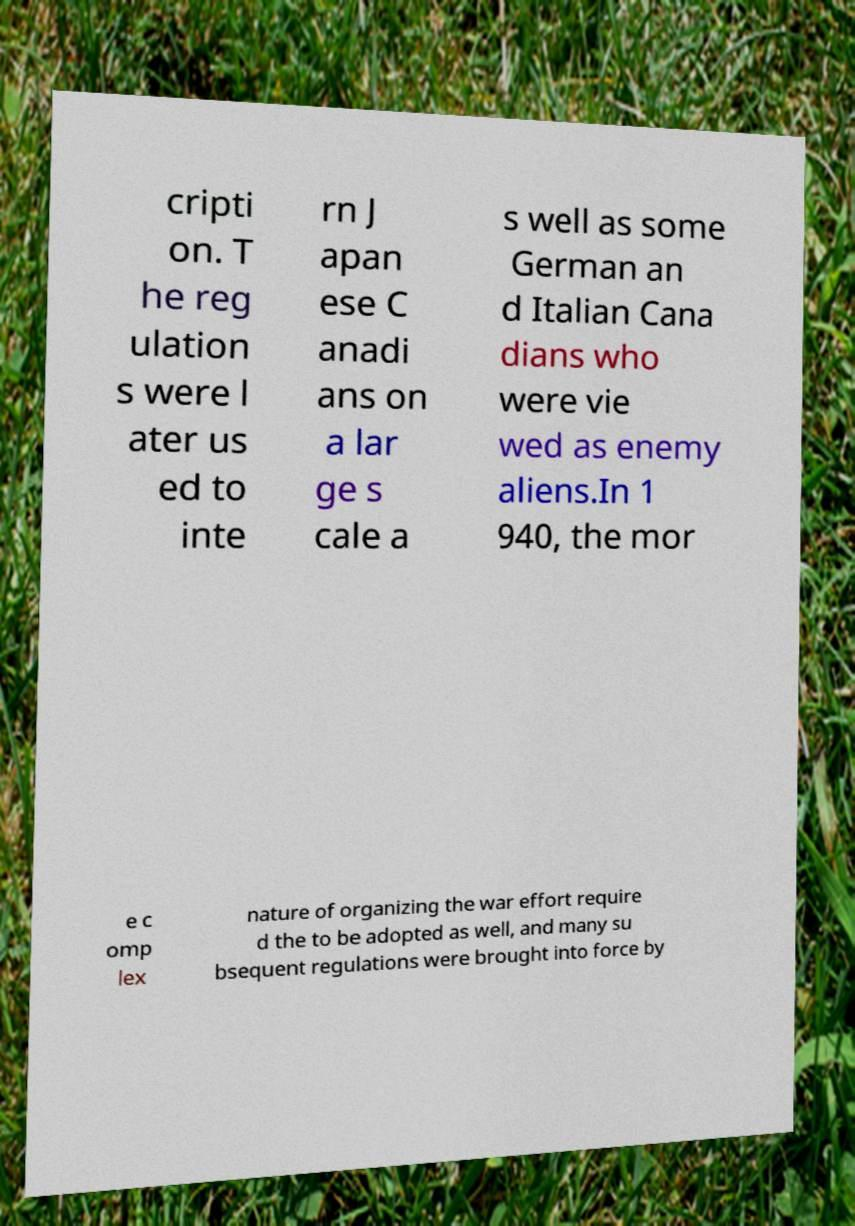I need the written content from this picture converted into text. Can you do that? cripti on. T he reg ulation s were l ater us ed to inte rn J apan ese C anadi ans on a lar ge s cale a s well as some German an d Italian Cana dians who were vie wed as enemy aliens.In 1 940, the mor e c omp lex nature of organizing the war effort require d the to be adopted as well, and many su bsequent regulations were brought into force by 